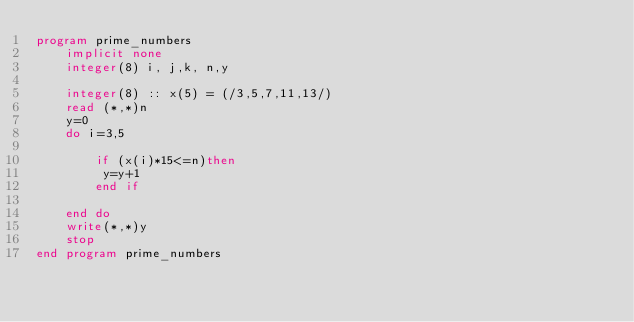Convert code to text. <code><loc_0><loc_0><loc_500><loc_500><_FORTRAN_>program prime_numbers
    implicit none
    integer(8) i, j,k, n,y
    
    integer(8) :: x(5) = (/3,5,7,11,13/)
    read (*,*)n
    y=0
    do i=3,5
                 
        if (x(i)*15<=n)then
         y=y+1
        end if

    end do
    write(*,*)y
    stop
end program prime_numbers</code> 